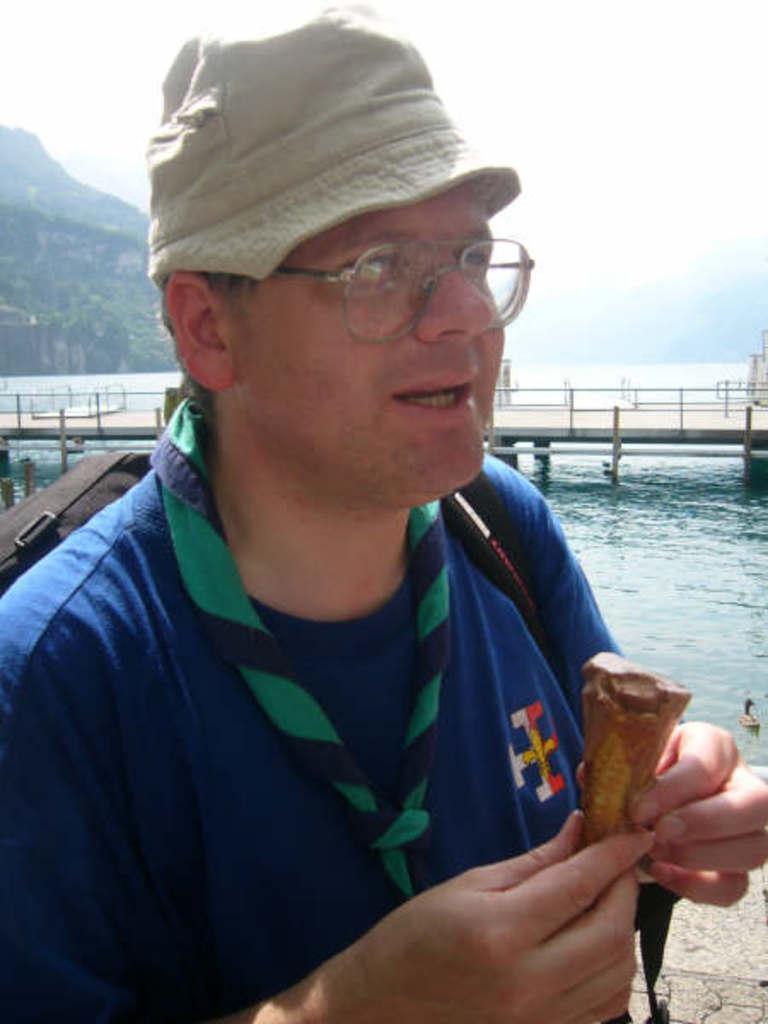Could you give a brief overview of what you see in this image? Here I can see a person wearing a bag, cap on the head, holding an ice cream in the hands and looking at the right side. In the background there is an ocean and also I can see a bridge. On the left side there is a mountain. At the top of the image I can see the sky. 